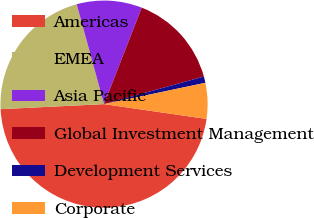Convert chart to OTSL. <chart><loc_0><loc_0><loc_500><loc_500><pie_chart><fcel>Americas<fcel>EMEA<fcel>Asia Pacific<fcel>Global Investment Management<fcel>Development Services<fcel>Corporate<nl><fcel>46.95%<fcel>21.52%<fcel>10.18%<fcel>14.78%<fcel>0.99%<fcel>5.58%<nl></chart> 